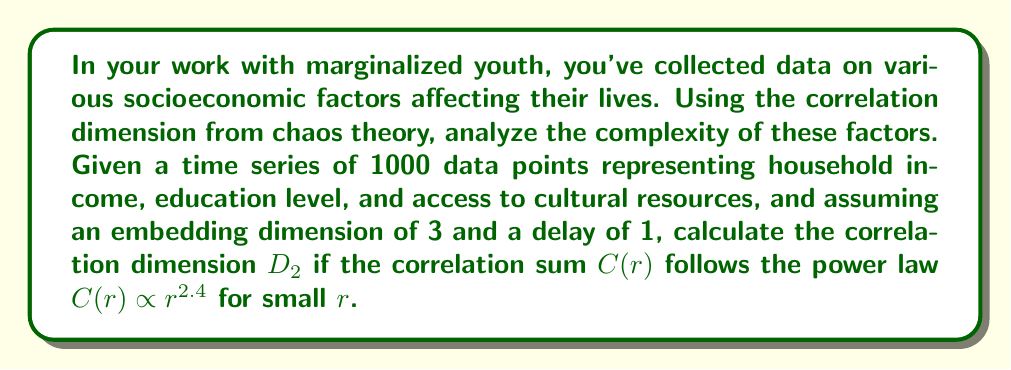Give your solution to this math problem. To compute the correlation dimension $D_2$, we follow these steps:

1) The correlation sum $C(r)$ is given by the power law:

   $$C(r) \propto r^{D_2}$$

2) We're told that $C(r) \propto r^{2.4}$ for small $r$.

3) Comparing these two equations, we can see that the exponent $2.4$ is equal to $D_2$:

   $$r^{D_2} = r^{2.4}$$

4) Therefore, the correlation dimension $D_2$ is directly given by the exponent in the power law relation:

   $$D_2 = 2.4$$

5) This non-integer dimension suggests that the socioeconomic factors affecting marginalized youth exhibit fractal-like behavior, indicating a complex, nonlinear system with self-similarity across scales.

6) In the context of your work, this implies that the interplay between household income, education level, and access to cultural resources creates a multifaceted environment for marginalized youth that cannot be fully captured by simple linear models.
Answer: $D_2 = 2.4$ 